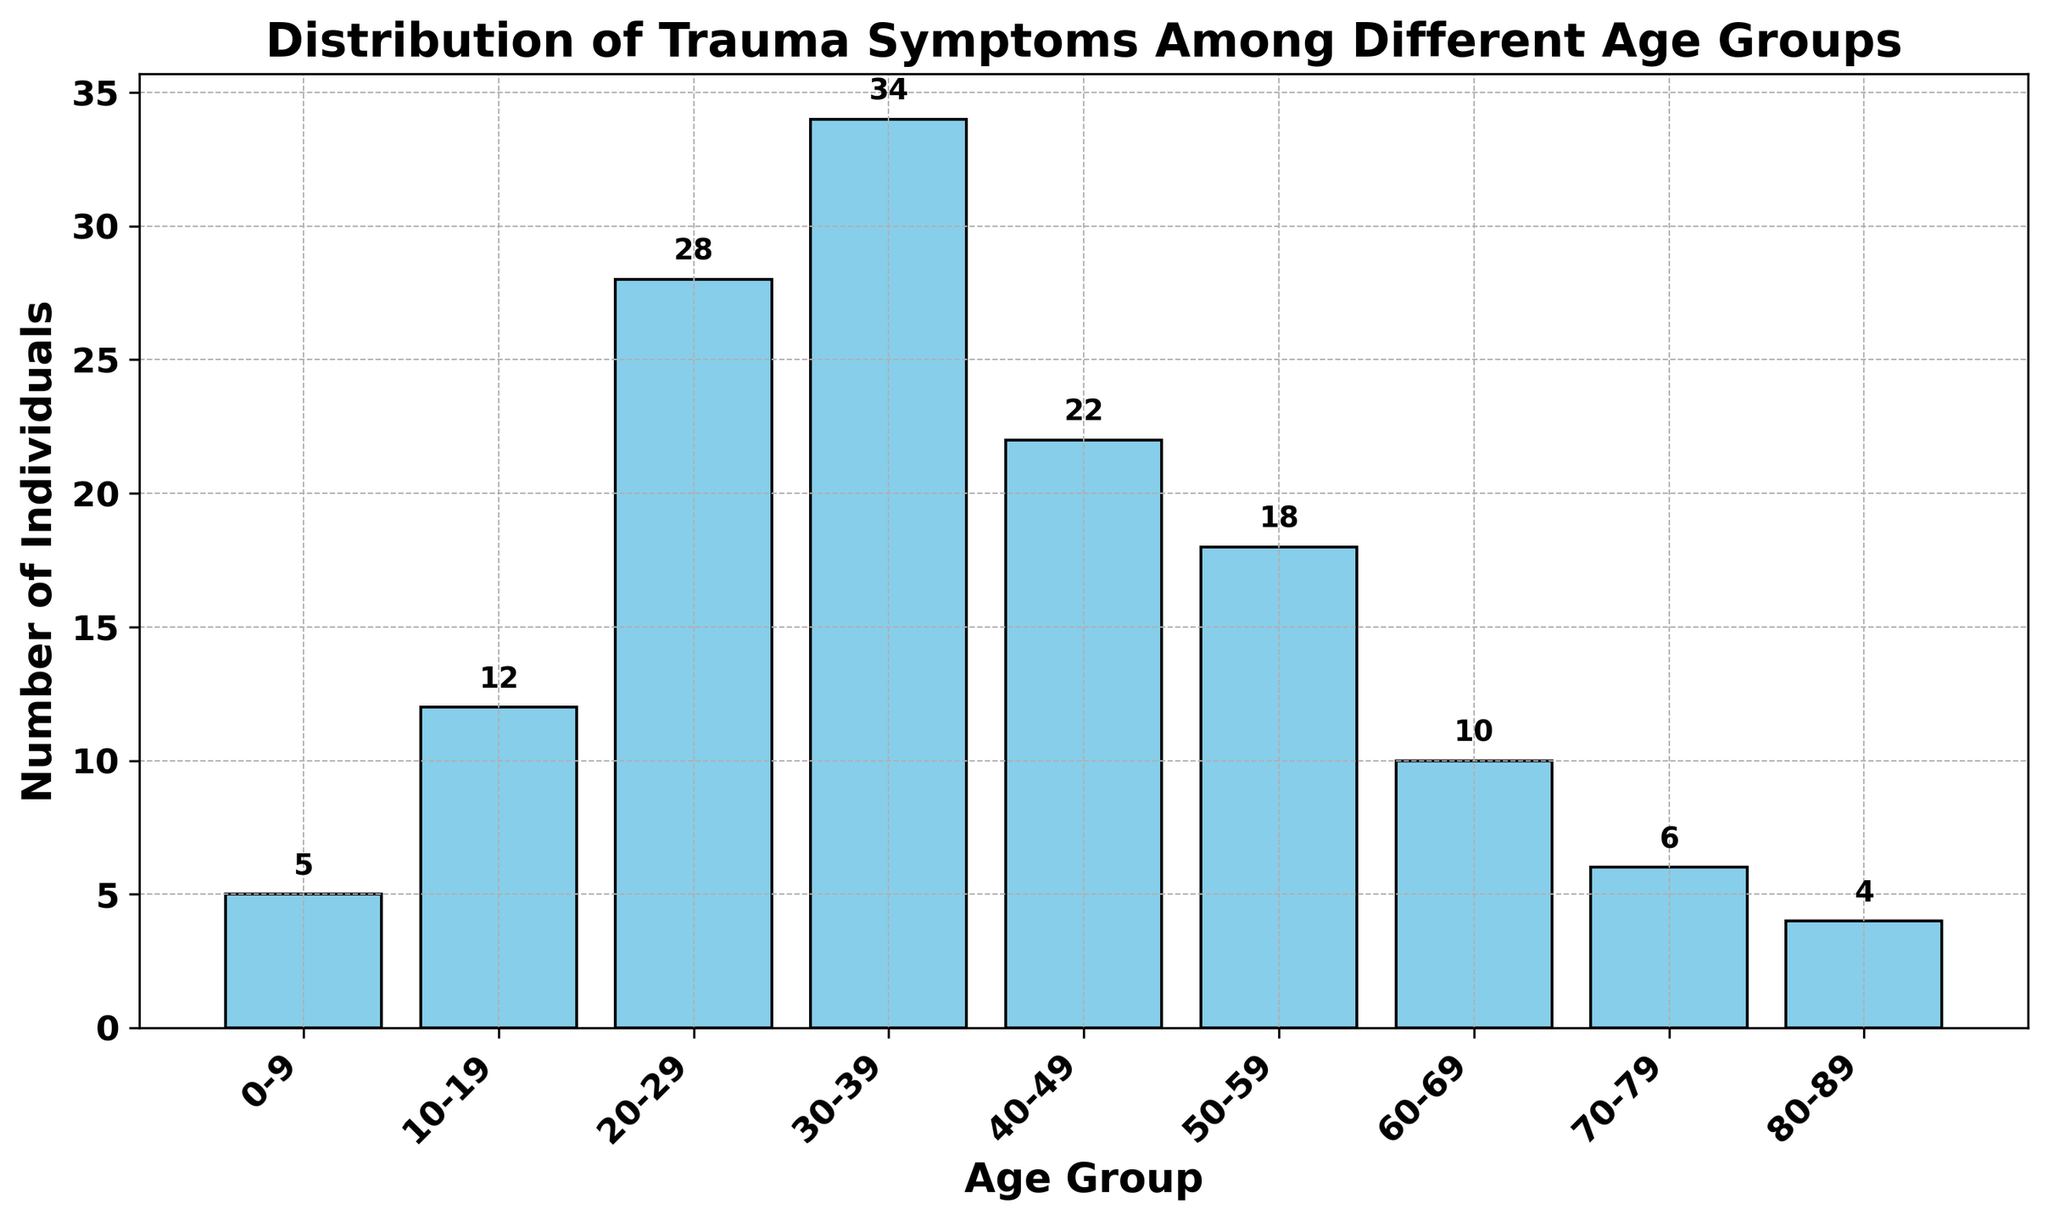Which age group has the highest number of individuals with trauma symptoms? The bar representing the 30-39 age group is the tallest, indicating it has the highest count.
Answer: 30-39 Which two age groups have the least number of individuals with trauma symptoms? The bars representing the 80-89 and 0-9 age groups are the shortest, indicating they have the lowest counts.
Answer: 80-89 and 0-9 How many more individuals are there with trauma symptoms in the 30-39 age group compared to the 60-69 age group? The 30-39 age group has 34 individuals, and the 60-69 age group has 10 individuals. The difference is 34 - 10.
Answer: 24 What is the average number of individuals with trauma symptoms across all age groups? Sum all the values: 5 + 12 + 28 + 34 + 22 + 18 + 10 + 6 + 4 = 139. There are 9 age groups, so the average is 139 / 9.
Answer: 15.44 Is there a significant difference in the number of individuals between the 20-29 and 40-49 age groups? The 20-29 age group has 28 individuals, and the 40-49 age group has 22 individuals. The difference is 28 - 22.
Answer: 6 How many age groups have fewer than 10 individuals with trauma symptoms? The bars for the 0-9, 70-79, and 80-89 age groups are shorter than 10, indicating they each have fewer than 10 individuals.
Answer: 3 Which age group has almost twice the number of individuals as the 50-59 age group? The 50-59 age group has 18 individuals. The 30-39 age group with 34 individuals is close to twice that number.
Answer: 30-39 Does the number of individuals with trauma symptoms consistently increase or decrease with age? The bars show a rise from the 0-9 age group to the 30-39 age group, after which there is a general decline.
Answer: Increases, then decreases What's the combined number of individuals with trauma symptoms in the 10-19 and 20-29 age groups? Sum the values for the 10-19 and 20-29 age groups: 12 + 28.
Answer: 40 